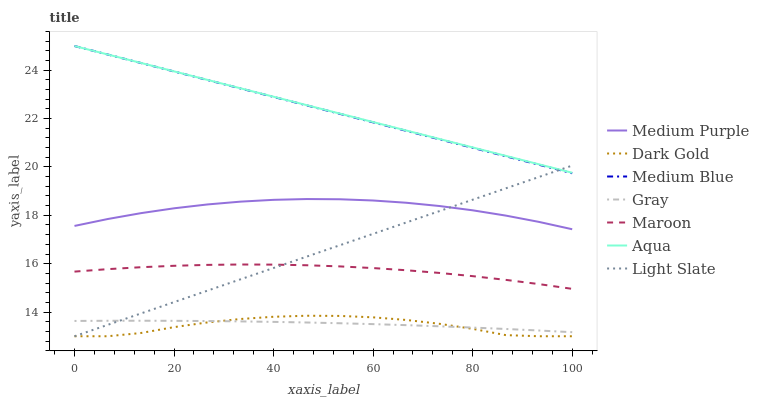Does Dark Gold have the minimum area under the curve?
Answer yes or no. Yes. Does Aqua have the maximum area under the curve?
Answer yes or no. Yes. Does Light Slate have the minimum area under the curve?
Answer yes or no. No. Does Light Slate have the maximum area under the curve?
Answer yes or no. No. Is Aqua the smoothest?
Answer yes or no. Yes. Is Dark Gold the roughest?
Answer yes or no. Yes. Is Light Slate the smoothest?
Answer yes or no. No. Is Light Slate the roughest?
Answer yes or no. No. Does Medium Blue have the lowest value?
Answer yes or no. No. Does Aqua have the highest value?
Answer yes or no. Yes. Does Dark Gold have the highest value?
Answer yes or no. No. Is Dark Gold less than Medium Purple?
Answer yes or no. Yes. Is Medium Blue greater than Maroon?
Answer yes or no. Yes. Does Gray intersect Dark Gold?
Answer yes or no. Yes. Is Gray less than Dark Gold?
Answer yes or no. No. Is Gray greater than Dark Gold?
Answer yes or no. No. Does Dark Gold intersect Medium Purple?
Answer yes or no. No. 